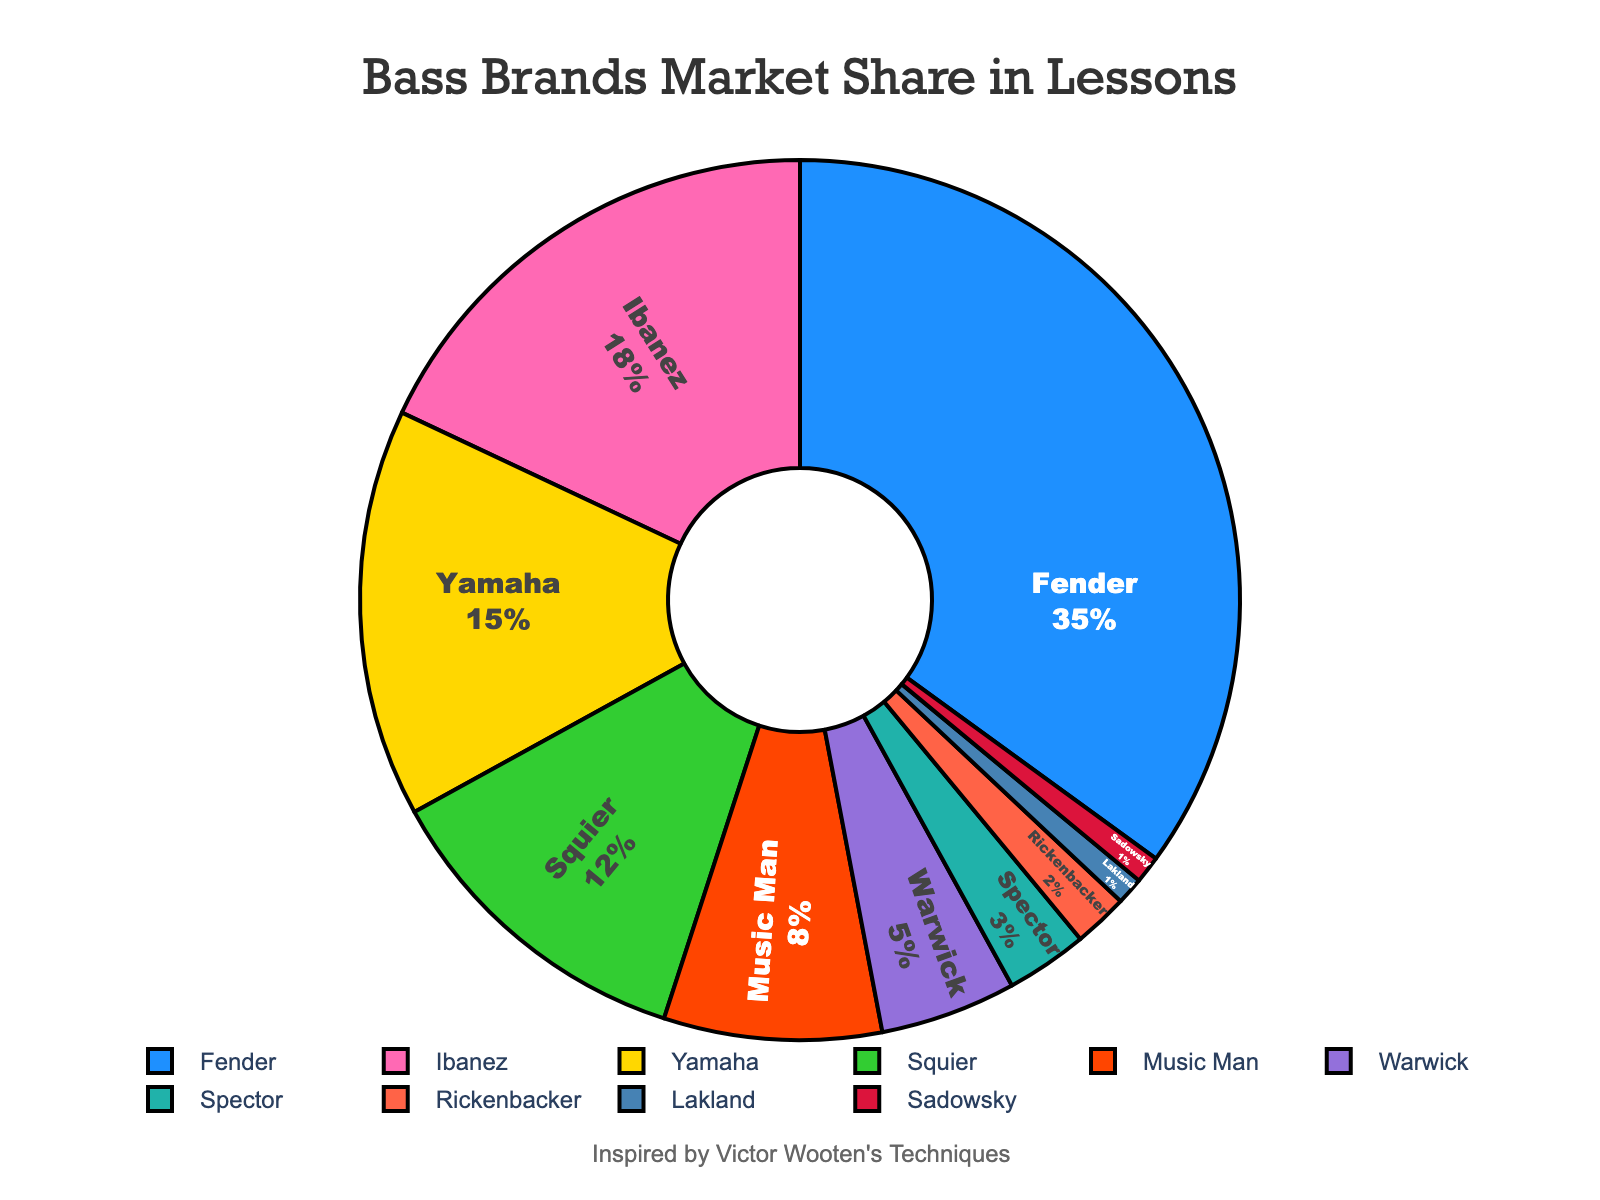Which brand holds the largest market share? By looking at the pie chart, the largest segment with the label showing the highest percentage is identified.
Answer: Fender What is the combined market share of Yamaha and Squier? Add the percentages of Yamaha and Squier from the chart: 15% + 12% = 27%.
Answer: 27% Which brand has a larger market share, Ibanez or Music Man? Compare the percentages of Ibanez (18%) and Music Man (8%) from the pie chart. Ibanez is larger.
Answer: Ibanez Is the market share of Spector greater than, less than, or equal to Rickenbacker and Lakland combined? Calculate the combined percentage of Rickenbacker and Lakland: 2% + 1% = 3%. Compare it with Spector's 3%. Both are equal.
Answer: Equal What is the total market share of the three brands with the smallest market shares? Add the percentages of Spector, Rickenbacker, and Lakland: 3% + 2% + 1% = 6%.
Answer: 6% How much more market share does Fender have than Music Man? Subtract the percentage of Music Man from Fender: 35% - 8% = 27%.
Answer: 27% Which color is used to represent Warwick in the chart? Identify the segment colored in a distinct color that is labeled "Warwick".
Answer: Purple How many brands have a market share greater than 10%? Count the segments labeled with more than 10%: Fender (35%), Ibanez (18%), Yamaha (15%), Squier (12%). There are four brands.
Answer: 4 What is the difference in market share between the most popular and the least popular brands? Subtract the smallest percentage (1% for Lakland and Sadowsky) from the largest (35% for Fender): 35% - 1% = 34%.
Answer: 34% If you combine the market shares of Ibanez and Yamaha, how does it compare to Fender? Add Ibanez and Yamaha’s percentages: 18% + 15% = 33%. Compare with Fender’s 35%. 33% is less than 35%.
Answer: Less 